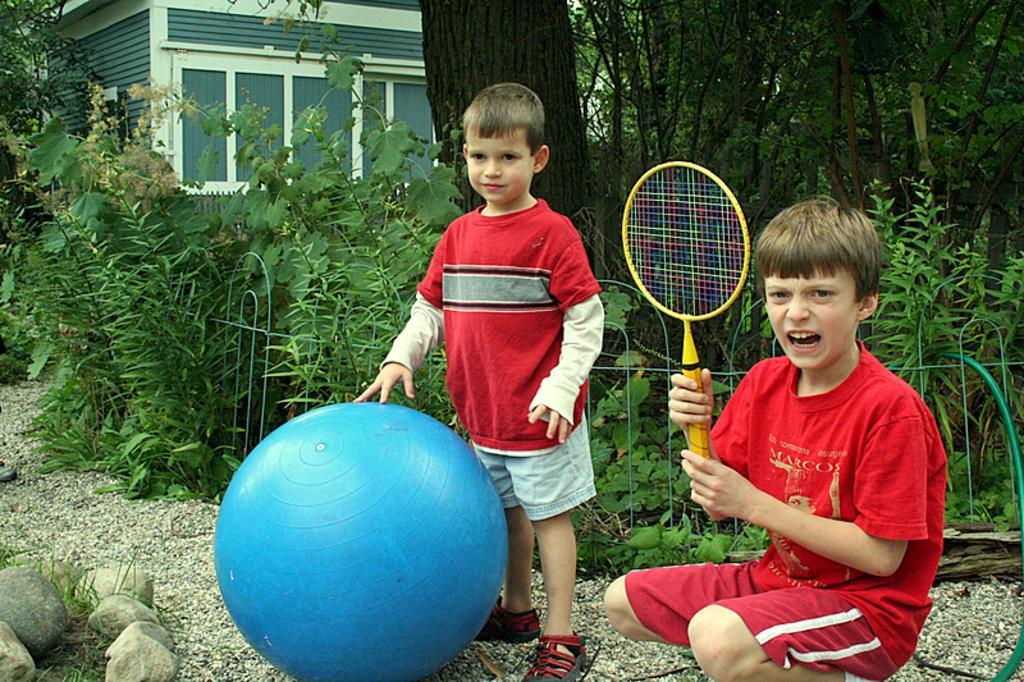Please provide a concise description of this image. The picture is taken outside of the house where two children are present and at the right corner the boy is dressed in red dress and holding a bat and in the middle another boy is standing and wearing red shirt and shorts and touching a big ball and behind them there are plants and trees. 